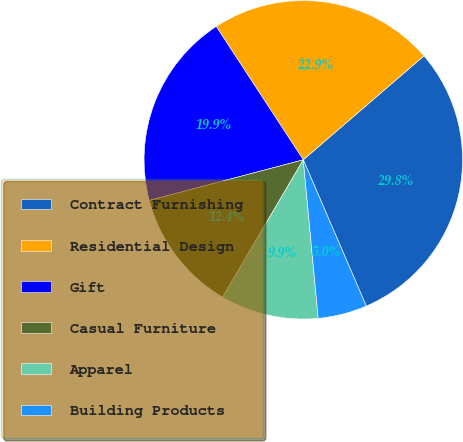Convert chart. <chart><loc_0><loc_0><loc_500><loc_500><pie_chart><fcel>Contract Furnishing<fcel>Residential Design<fcel>Gift<fcel>Casual Furniture<fcel>Apparel<fcel>Building Products<nl><fcel>29.85%<fcel>22.89%<fcel>19.9%<fcel>12.44%<fcel>9.95%<fcel>4.98%<nl></chart> 